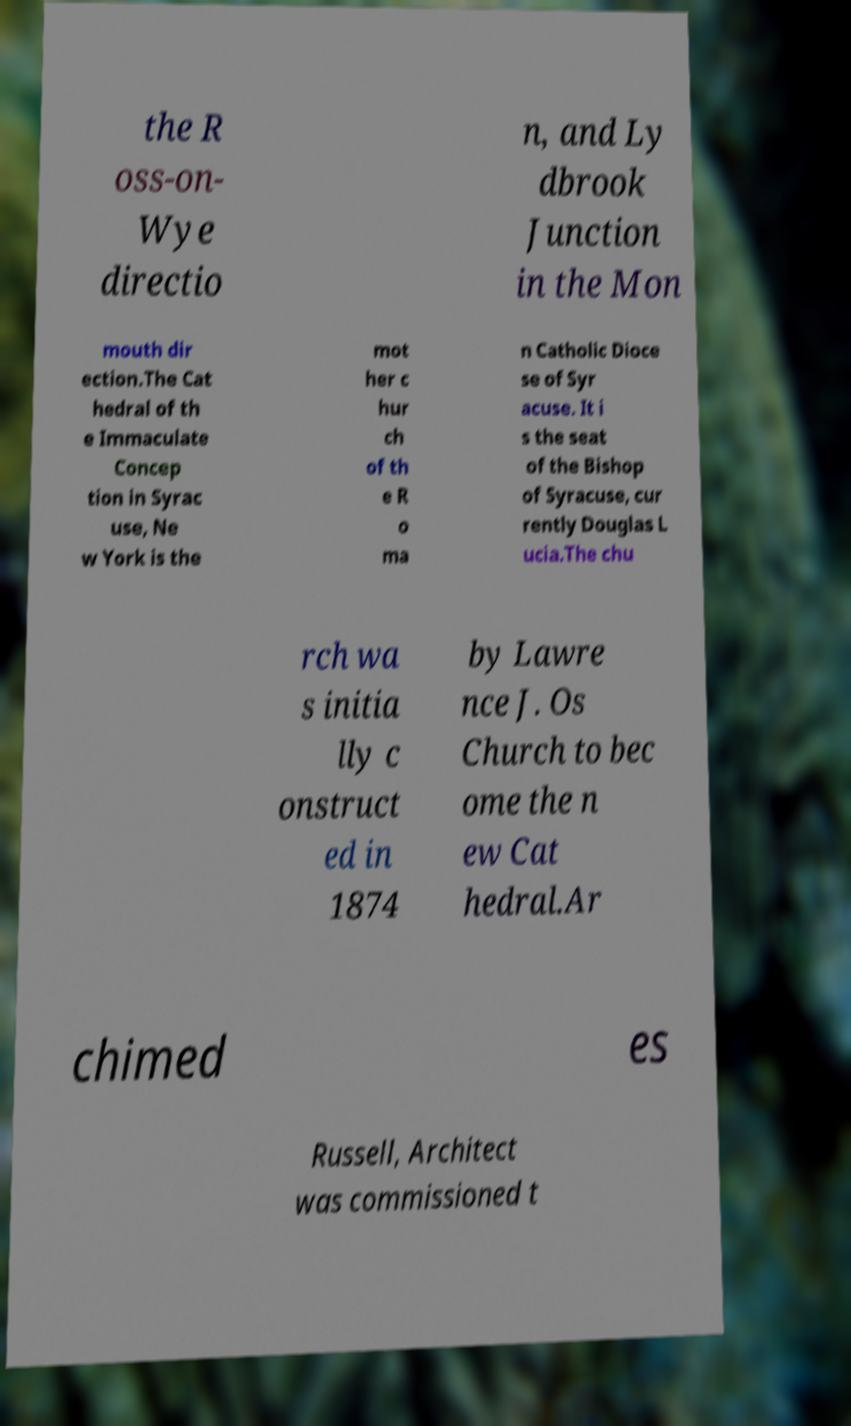I need the written content from this picture converted into text. Can you do that? the R oss-on- Wye directio n, and Ly dbrook Junction in the Mon mouth dir ection.The Cat hedral of th e Immaculate Concep tion in Syrac use, Ne w York is the mot her c hur ch of th e R o ma n Catholic Dioce se of Syr acuse. It i s the seat of the Bishop of Syracuse, cur rently Douglas L ucia.The chu rch wa s initia lly c onstruct ed in 1874 by Lawre nce J. Os Church to bec ome the n ew Cat hedral.Ar chimed es Russell, Architect was commissioned t 